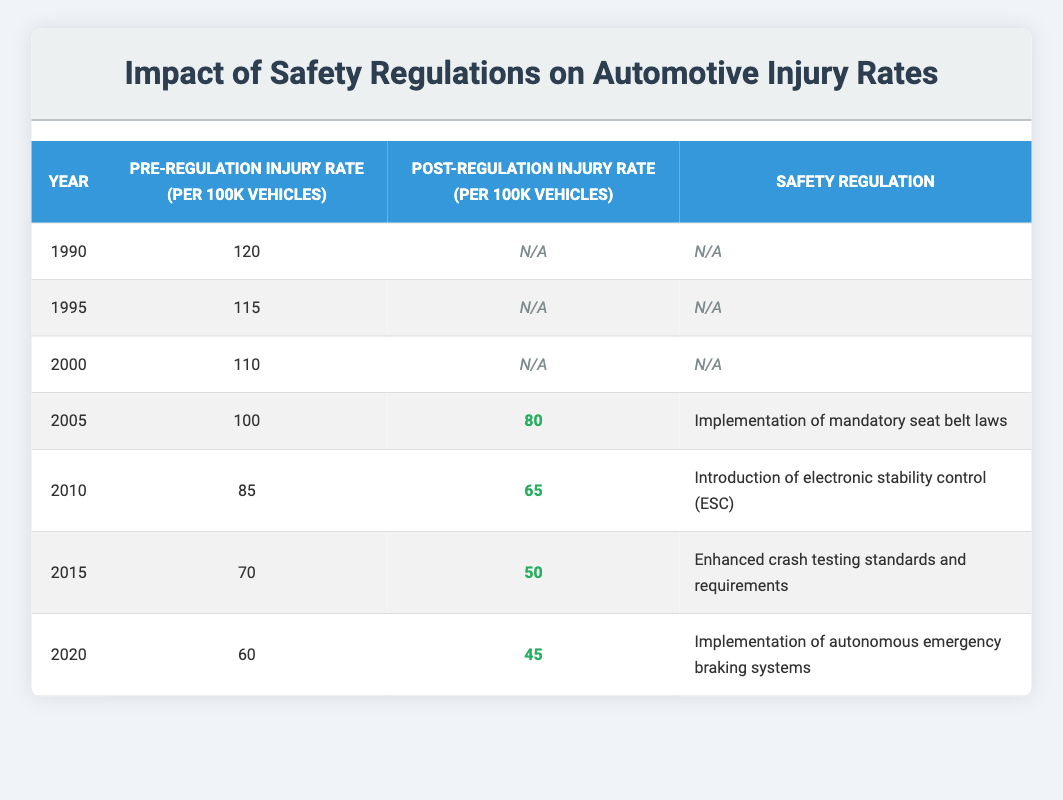What was the pre-regulation injury rate in 2000? The table lists the pre-regulation injury rate for 2000 as 110 per 100k vehicles.
Answer: 110 What safety regulation was implemented in 2010? The table indicates that the safety regulation implemented in 2010 was the introduction of electronic stability control (ESC).
Answer: Introduction of electronic stability control (ESC) What is the reduction in injury rates from 2005 to 2010? The pre-regulation injury rate in 2005 was 100, and the post-regulation injury rate in 2010 was 65. The reduction is calculated as 100 - 65 = 35.
Answer: 35 Was there any reduction in injury rates after the implementation of mandatory seat belt laws in 2005? In 2005, the pre-regulation injury rate was 100, and the post-regulation rate was 80. Since 80 is less than 100, the injury rates did reduce after the implementation.
Answer: Yes What was the average post-regulation injury rate from 2005 to 2020? The post-regulation injury rates for the years 2005 (80), 2010 (65), 2015 (50), and 2020 (45) need to be summed: 80 + 65 + 50 + 45 = 240. There are 4 data points, so dividing gives an average of 240 / 4 = 60.
Answer: 60 What was the lowest pre-regulation injury rate recorded in the table? By examining the pre-regulation injury rates listed, the lowest rate of 60 per 100k vehicles was recorded in 2020.
Answer: 60 Was there an increase in injury rates from 1990 to 2000? The pre-regulation injury rates for 1990 was 120 and for 2000 was 110. Since 110 is less than 120, there was a decrease in injury rates.
Answer: No How much did the injury rate decrease from 2015 to 2020? The pre-regulation injury rate in 2015 was 70 and the post-regulation injury rate in 2020 was 45. The decrease is calculated as 70 - 45 = 25.
Answer: 25 